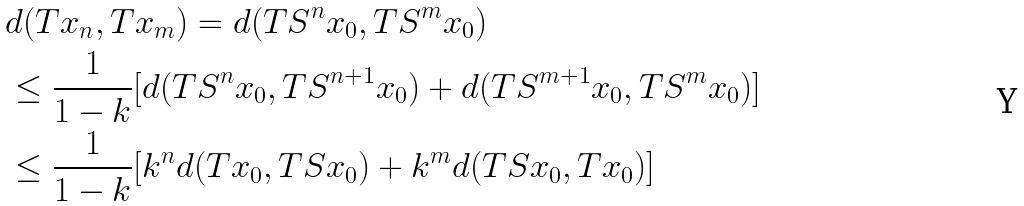Convert formula to latex. <formula><loc_0><loc_0><loc_500><loc_500>& d ( T x _ { n } , T x _ { m } ) = d ( T S ^ { n } x _ { 0 } , T S ^ { m } x _ { 0 } ) \\ & \leq \frac { 1 } { 1 - k } [ d ( T S ^ { n } x _ { 0 } , T S ^ { n + 1 } x _ { 0 } ) + d ( T S ^ { m + 1 } x _ { 0 } , T S ^ { m } x _ { 0 } ) ] \\ & \leq \frac { 1 } { 1 - k } [ k ^ { n } d ( T x _ { 0 } , T S x _ { 0 } ) + k ^ { m } d ( T S x _ { 0 } , T x _ { 0 } ) ]</formula> 